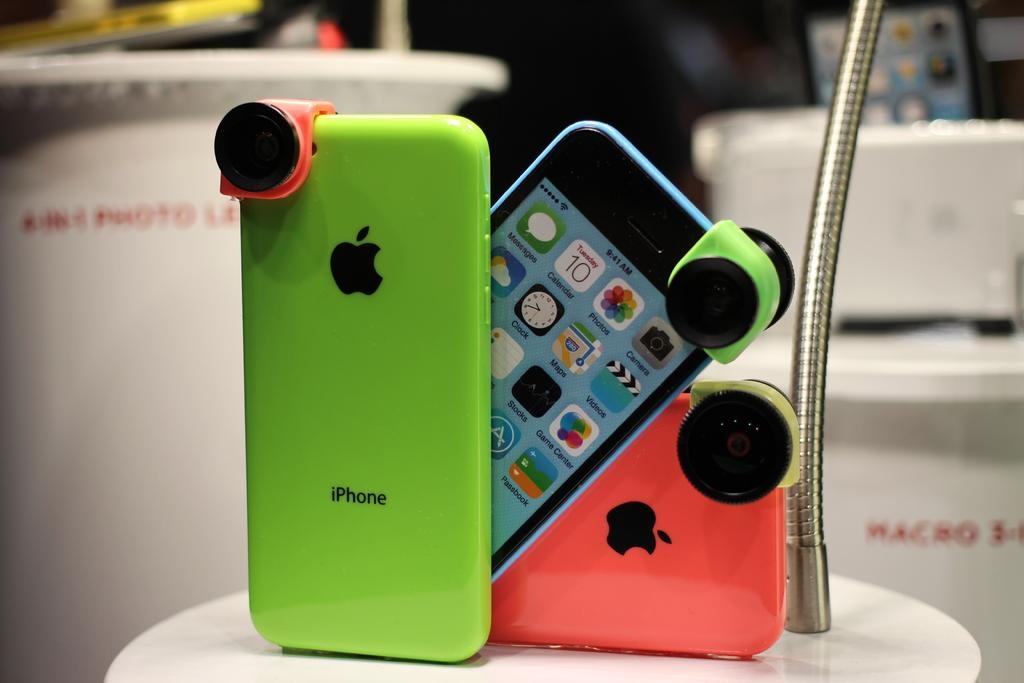<image>
Write a terse but informative summary of the picture. The brighly colored iPhones are on display at the store. 